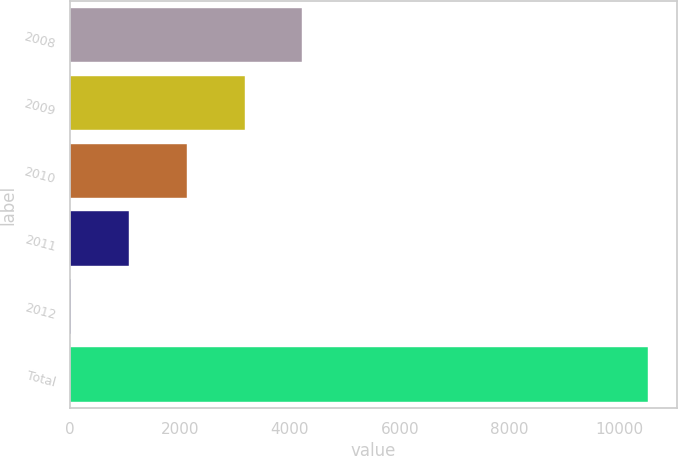Convert chart to OTSL. <chart><loc_0><loc_0><loc_500><loc_500><bar_chart><fcel>2008<fcel>2009<fcel>2010<fcel>2011<fcel>2012<fcel>Total<nl><fcel>4226.4<fcel>3176.3<fcel>2126.2<fcel>1076.1<fcel>26<fcel>10527<nl></chart> 